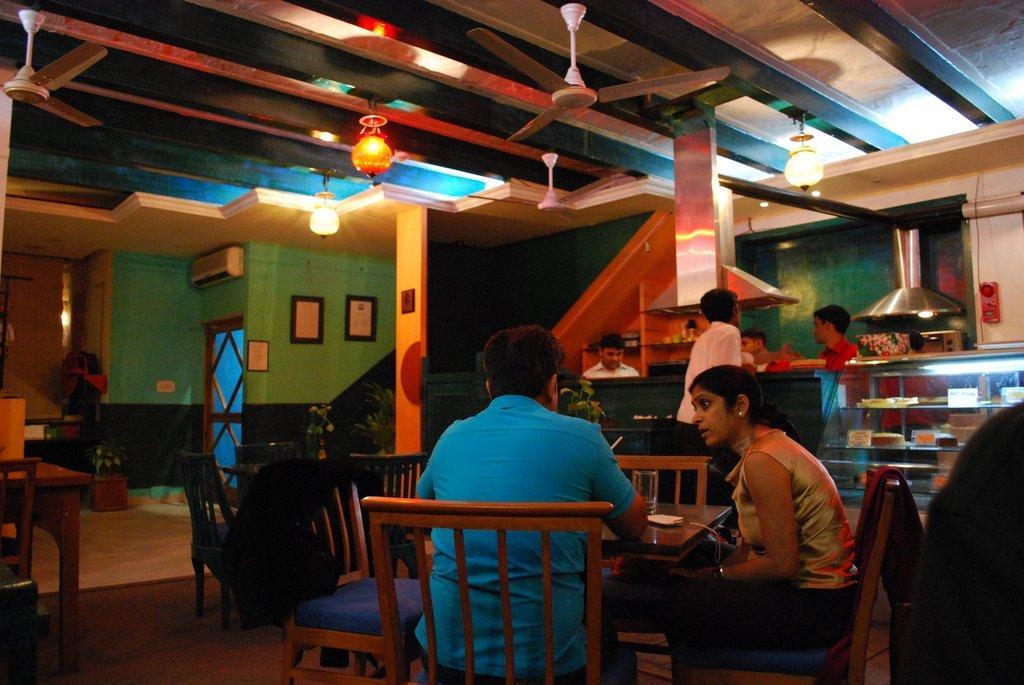Can you describe this image briefly? This image is taken inside a room. In the right side of the image a person is sitting on the chair. In the middle of the image a man and a woman are sitting on the chairs. In the left side of the image there is an empty table and chair. In the bottom of the image there is a floor. At the top of the image there is a ceiling with lights, lamps and fans. In the background there is a wall with doors, picture frames, switchboard and air conditioner on it. There is a chimney in the kitchen and there are few people standing and there are few cakes in the fridge. 